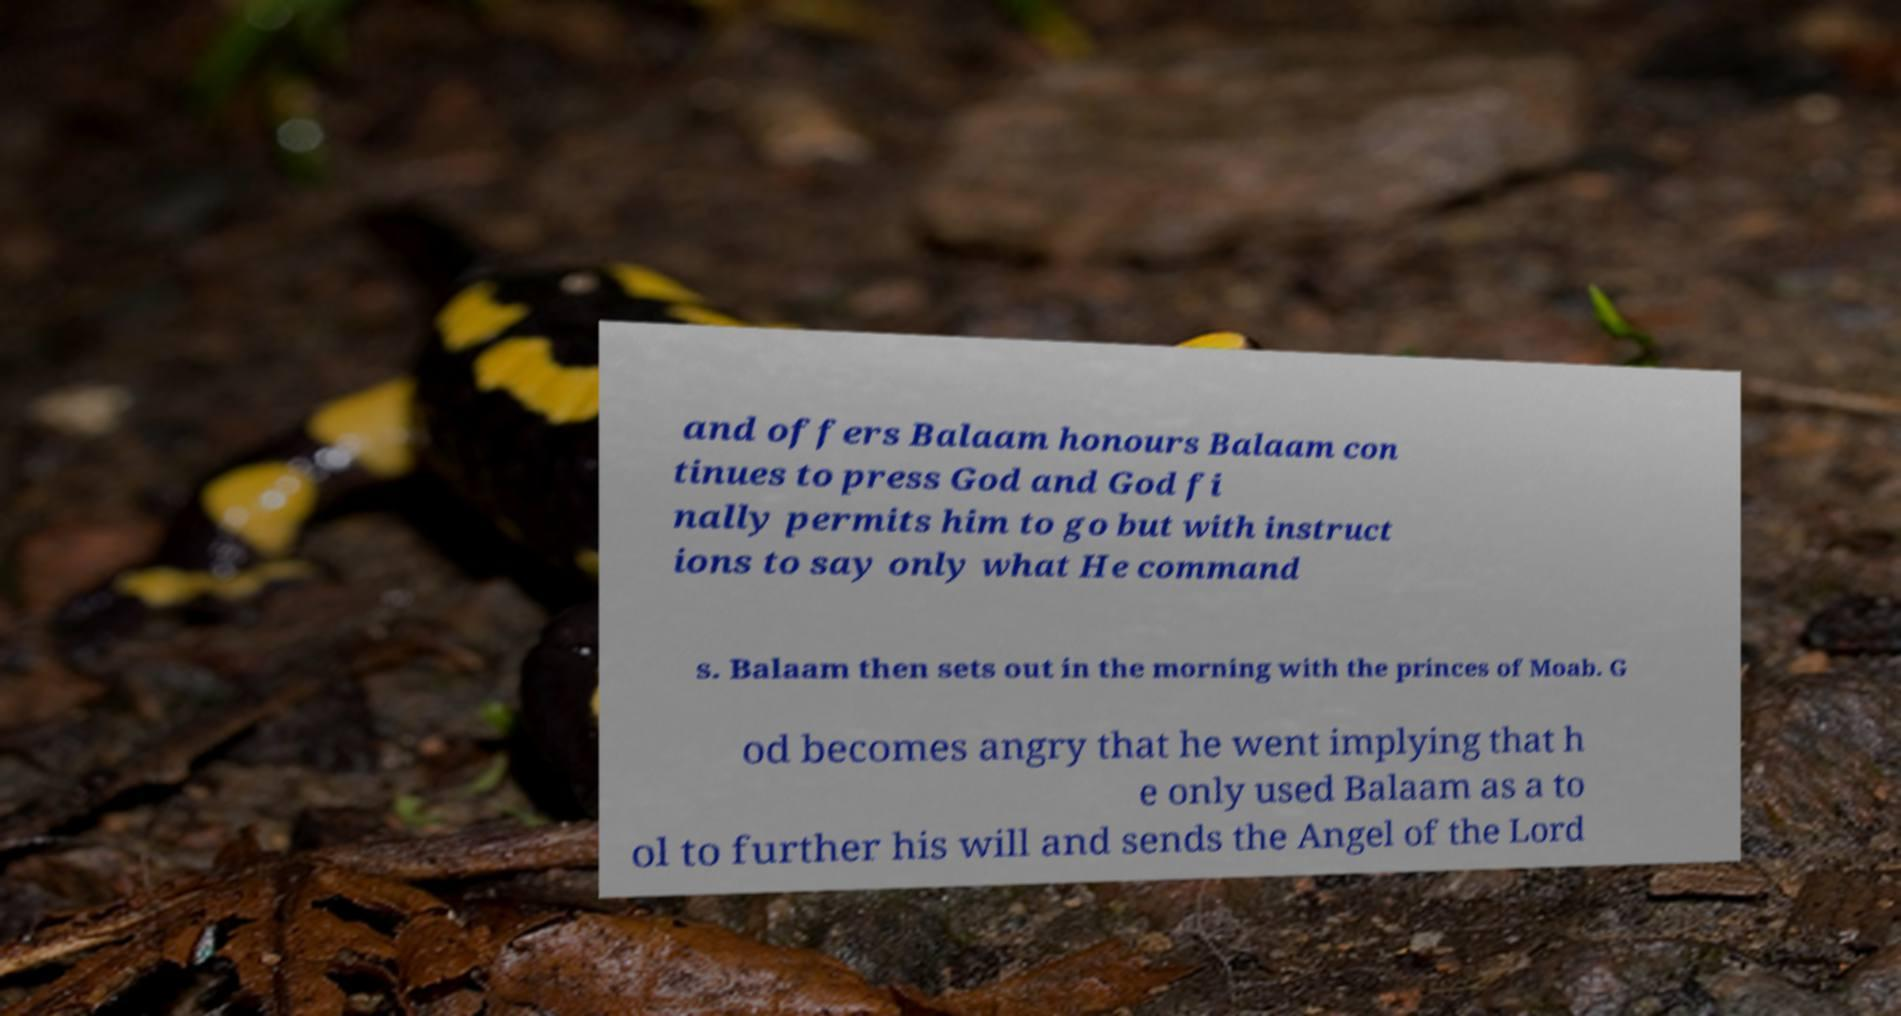Could you assist in decoding the text presented in this image and type it out clearly? and offers Balaam honours Balaam con tinues to press God and God fi nally permits him to go but with instruct ions to say only what He command s. Balaam then sets out in the morning with the princes of Moab. G od becomes angry that he went implying that h e only used Balaam as a to ol to further his will and sends the Angel of the Lord 